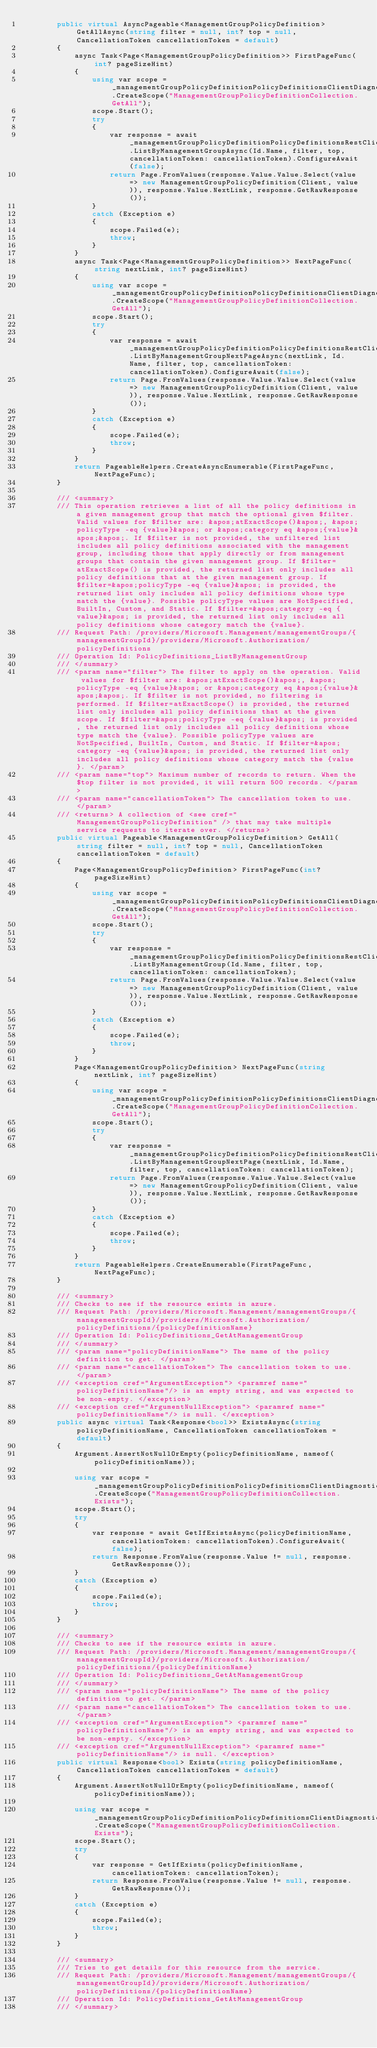<code> <loc_0><loc_0><loc_500><loc_500><_C#_>        public virtual AsyncPageable<ManagementGroupPolicyDefinition> GetAllAsync(string filter = null, int? top = null, CancellationToken cancellationToken = default)
        {
            async Task<Page<ManagementGroupPolicyDefinition>> FirstPageFunc(int? pageSizeHint)
            {
                using var scope = _managementGroupPolicyDefinitionPolicyDefinitionsClientDiagnostics.CreateScope("ManagementGroupPolicyDefinitionCollection.GetAll");
                scope.Start();
                try
                {
                    var response = await _managementGroupPolicyDefinitionPolicyDefinitionsRestClient.ListByManagementGroupAsync(Id.Name, filter, top, cancellationToken: cancellationToken).ConfigureAwait(false);
                    return Page.FromValues(response.Value.Value.Select(value => new ManagementGroupPolicyDefinition(Client, value)), response.Value.NextLink, response.GetRawResponse());
                }
                catch (Exception e)
                {
                    scope.Failed(e);
                    throw;
                }
            }
            async Task<Page<ManagementGroupPolicyDefinition>> NextPageFunc(string nextLink, int? pageSizeHint)
            {
                using var scope = _managementGroupPolicyDefinitionPolicyDefinitionsClientDiagnostics.CreateScope("ManagementGroupPolicyDefinitionCollection.GetAll");
                scope.Start();
                try
                {
                    var response = await _managementGroupPolicyDefinitionPolicyDefinitionsRestClient.ListByManagementGroupNextPageAsync(nextLink, Id.Name, filter, top, cancellationToken: cancellationToken).ConfigureAwait(false);
                    return Page.FromValues(response.Value.Value.Select(value => new ManagementGroupPolicyDefinition(Client, value)), response.Value.NextLink, response.GetRawResponse());
                }
                catch (Exception e)
                {
                    scope.Failed(e);
                    throw;
                }
            }
            return PageableHelpers.CreateAsyncEnumerable(FirstPageFunc, NextPageFunc);
        }

        /// <summary>
        /// This operation retrieves a list of all the policy definitions in a given management group that match the optional given $filter. Valid values for $filter are: &apos;atExactScope()&apos;, &apos;policyType -eq {value}&apos; or &apos;category eq &apos;{value}&apos;&apos;. If $filter is not provided, the unfiltered list includes all policy definitions associated with the management group, including those that apply directly or from management groups that contain the given management group. If $filter=atExactScope() is provided, the returned list only includes all policy definitions that at the given management group. If $filter=&apos;policyType -eq {value}&apos; is provided, the returned list only includes all policy definitions whose type match the {value}. Possible policyType values are NotSpecified, BuiltIn, Custom, and Static. If $filter=&apos;category -eq {value}&apos; is provided, the returned list only includes all policy definitions whose category match the {value}.
        /// Request Path: /providers/Microsoft.Management/managementGroups/{managementGroupId}/providers/Microsoft.Authorization/policyDefinitions
        /// Operation Id: PolicyDefinitions_ListByManagementGroup
        /// </summary>
        /// <param name="filter"> The filter to apply on the operation. Valid values for $filter are: &apos;atExactScope()&apos;, &apos;policyType -eq {value}&apos; or &apos;category eq &apos;{value}&apos;&apos;. If $filter is not provided, no filtering is performed. If $filter=atExactScope() is provided, the returned list only includes all policy definitions that at the given scope. If $filter=&apos;policyType -eq {value}&apos; is provided, the returned list only includes all policy definitions whose type match the {value}. Possible policyType values are NotSpecified, BuiltIn, Custom, and Static. If $filter=&apos;category -eq {value}&apos; is provided, the returned list only includes all policy definitions whose category match the {value}. </param>
        /// <param name="top"> Maximum number of records to return. When the $top filter is not provided, it will return 500 records. </param>
        /// <param name="cancellationToken"> The cancellation token to use. </param>
        /// <returns> A collection of <see cref="ManagementGroupPolicyDefinition" /> that may take multiple service requests to iterate over. </returns>
        public virtual Pageable<ManagementGroupPolicyDefinition> GetAll(string filter = null, int? top = null, CancellationToken cancellationToken = default)
        {
            Page<ManagementGroupPolicyDefinition> FirstPageFunc(int? pageSizeHint)
            {
                using var scope = _managementGroupPolicyDefinitionPolicyDefinitionsClientDiagnostics.CreateScope("ManagementGroupPolicyDefinitionCollection.GetAll");
                scope.Start();
                try
                {
                    var response = _managementGroupPolicyDefinitionPolicyDefinitionsRestClient.ListByManagementGroup(Id.Name, filter, top, cancellationToken: cancellationToken);
                    return Page.FromValues(response.Value.Value.Select(value => new ManagementGroupPolicyDefinition(Client, value)), response.Value.NextLink, response.GetRawResponse());
                }
                catch (Exception e)
                {
                    scope.Failed(e);
                    throw;
                }
            }
            Page<ManagementGroupPolicyDefinition> NextPageFunc(string nextLink, int? pageSizeHint)
            {
                using var scope = _managementGroupPolicyDefinitionPolicyDefinitionsClientDiagnostics.CreateScope("ManagementGroupPolicyDefinitionCollection.GetAll");
                scope.Start();
                try
                {
                    var response = _managementGroupPolicyDefinitionPolicyDefinitionsRestClient.ListByManagementGroupNextPage(nextLink, Id.Name, filter, top, cancellationToken: cancellationToken);
                    return Page.FromValues(response.Value.Value.Select(value => new ManagementGroupPolicyDefinition(Client, value)), response.Value.NextLink, response.GetRawResponse());
                }
                catch (Exception e)
                {
                    scope.Failed(e);
                    throw;
                }
            }
            return PageableHelpers.CreateEnumerable(FirstPageFunc, NextPageFunc);
        }

        /// <summary>
        /// Checks to see if the resource exists in azure.
        /// Request Path: /providers/Microsoft.Management/managementGroups/{managementGroupId}/providers/Microsoft.Authorization/policyDefinitions/{policyDefinitionName}
        /// Operation Id: PolicyDefinitions_GetAtManagementGroup
        /// </summary>
        /// <param name="policyDefinitionName"> The name of the policy definition to get. </param>
        /// <param name="cancellationToken"> The cancellation token to use. </param>
        /// <exception cref="ArgumentException"> <paramref name="policyDefinitionName"/> is an empty string, and was expected to be non-empty. </exception>
        /// <exception cref="ArgumentNullException"> <paramref name="policyDefinitionName"/> is null. </exception>
        public async virtual Task<Response<bool>> ExistsAsync(string policyDefinitionName, CancellationToken cancellationToken = default)
        {
            Argument.AssertNotNullOrEmpty(policyDefinitionName, nameof(policyDefinitionName));

            using var scope = _managementGroupPolicyDefinitionPolicyDefinitionsClientDiagnostics.CreateScope("ManagementGroupPolicyDefinitionCollection.Exists");
            scope.Start();
            try
            {
                var response = await GetIfExistsAsync(policyDefinitionName, cancellationToken: cancellationToken).ConfigureAwait(false);
                return Response.FromValue(response.Value != null, response.GetRawResponse());
            }
            catch (Exception e)
            {
                scope.Failed(e);
                throw;
            }
        }

        /// <summary>
        /// Checks to see if the resource exists in azure.
        /// Request Path: /providers/Microsoft.Management/managementGroups/{managementGroupId}/providers/Microsoft.Authorization/policyDefinitions/{policyDefinitionName}
        /// Operation Id: PolicyDefinitions_GetAtManagementGroup
        /// </summary>
        /// <param name="policyDefinitionName"> The name of the policy definition to get. </param>
        /// <param name="cancellationToken"> The cancellation token to use. </param>
        /// <exception cref="ArgumentException"> <paramref name="policyDefinitionName"/> is an empty string, and was expected to be non-empty. </exception>
        /// <exception cref="ArgumentNullException"> <paramref name="policyDefinitionName"/> is null. </exception>
        public virtual Response<bool> Exists(string policyDefinitionName, CancellationToken cancellationToken = default)
        {
            Argument.AssertNotNullOrEmpty(policyDefinitionName, nameof(policyDefinitionName));

            using var scope = _managementGroupPolicyDefinitionPolicyDefinitionsClientDiagnostics.CreateScope("ManagementGroupPolicyDefinitionCollection.Exists");
            scope.Start();
            try
            {
                var response = GetIfExists(policyDefinitionName, cancellationToken: cancellationToken);
                return Response.FromValue(response.Value != null, response.GetRawResponse());
            }
            catch (Exception e)
            {
                scope.Failed(e);
                throw;
            }
        }

        /// <summary>
        /// Tries to get details for this resource from the service.
        /// Request Path: /providers/Microsoft.Management/managementGroups/{managementGroupId}/providers/Microsoft.Authorization/policyDefinitions/{policyDefinitionName}
        /// Operation Id: PolicyDefinitions_GetAtManagementGroup
        /// </summary></code> 